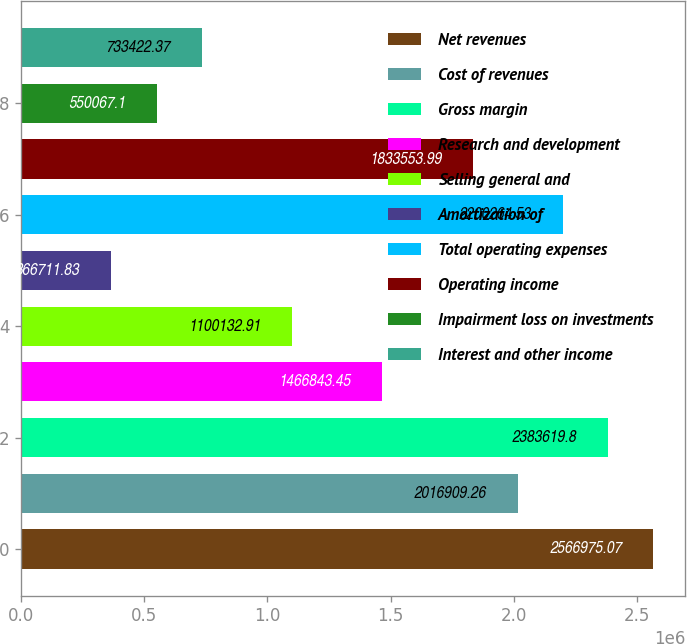<chart> <loc_0><loc_0><loc_500><loc_500><bar_chart><fcel>Net revenues<fcel>Cost of revenues<fcel>Gross margin<fcel>Research and development<fcel>Selling general and<fcel>Amortization of<fcel>Total operating expenses<fcel>Operating income<fcel>Impairment loss on investments<fcel>Interest and other income<nl><fcel>2.56698e+06<fcel>2.01691e+06<fcel>2.38362e+06<fcel>1.46684e+06<fcel>1.10013e+06<fcel>366712<fcel>2.20026e+06<fcel>1.83355e+06<fcel>550067<fcel>733422<nl></chart> 